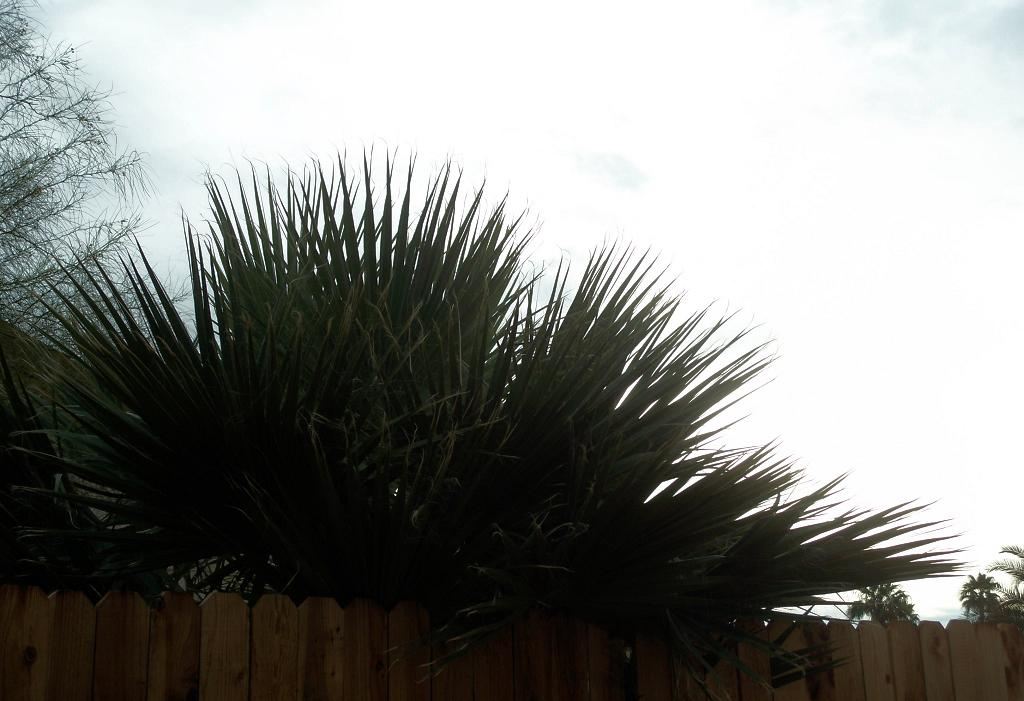What type of structure can be seen in the image? There is a fence in the image. What other natural elements are present in the image? There are trees in the image. What part of the environment is visible in the image? The sky is visible in the image. When was the image taken? The image was taken during the day. What is the opinion of the trees in the image? There is no opinion present in the image, as it only contains visual elements. 